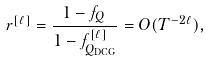Convert formula to latex. <formula><loc_0><loc_0><loc_500><loc_500>r ^ { [ \ell ] } = \frac { 1 - f _ { Q } \, } { 1 - f _ { Q _ { \text {DCG} } } ^ { [ \ell ] } } = O ( T ^ { - 2 \ell } ) ,</formula> 